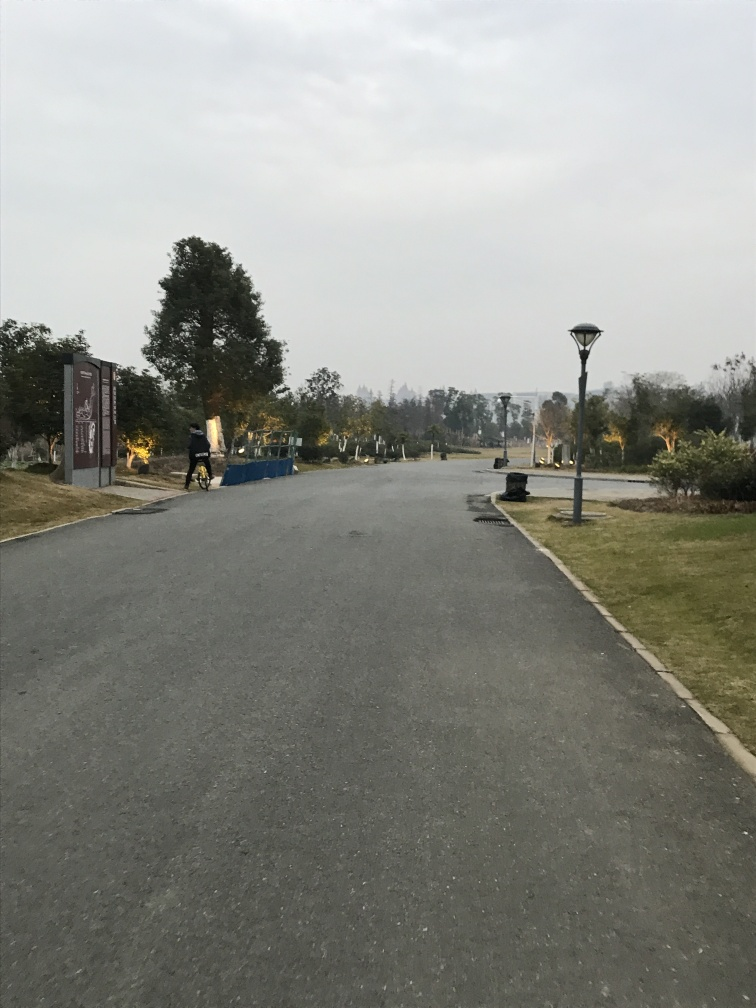Can you describe the atmosphere of this place? The atmosphere seems peaceful and quiet, possibly a park or campus road meant for leisurely walks or tranquil commutes, away from the hustle of city life. What activities do you think are common here? Given the surroundings, activities like jogging, biking, or a casual stroll would be well-suited for this path lined with lampposts for illumination during the early morning or evening hours. 